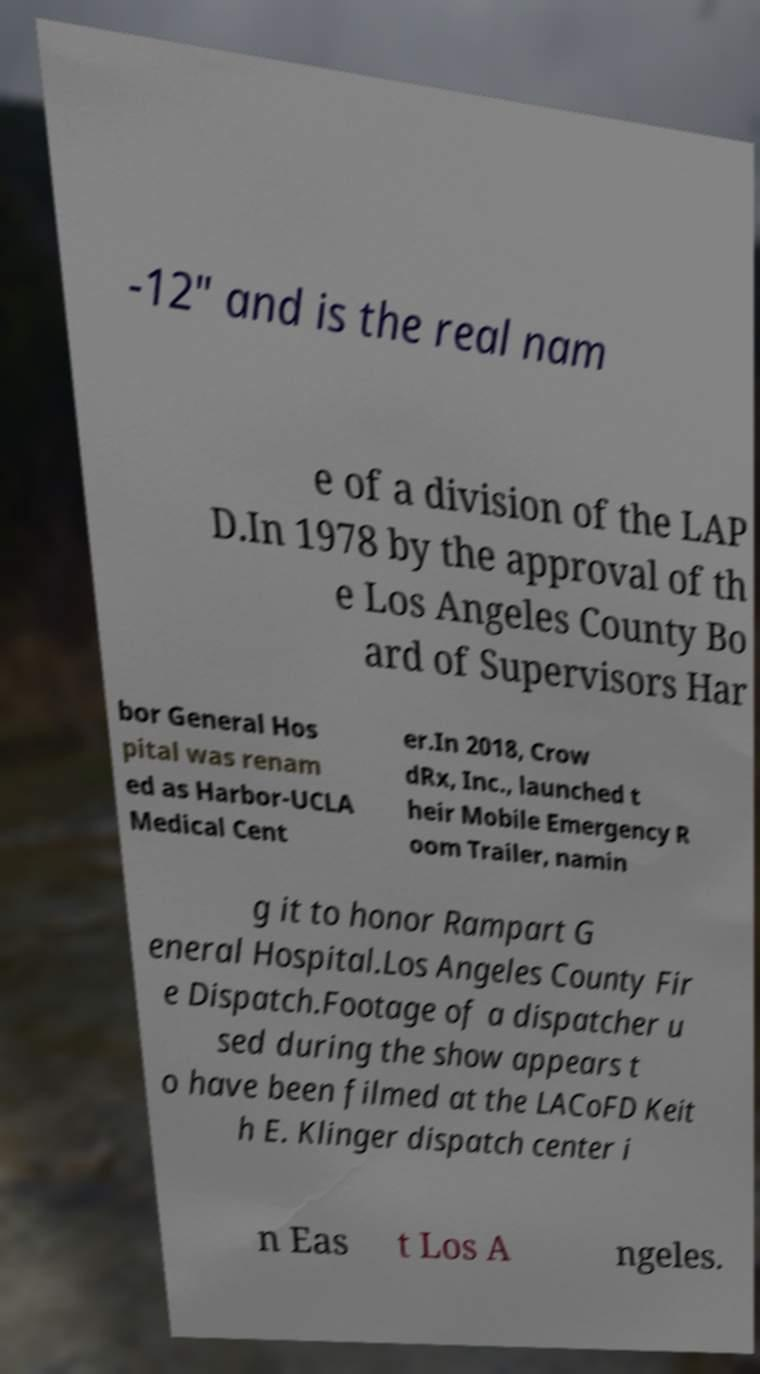Please read and relay the text visible in this image. What does it say? -12" and is the real nam e of a division of the LAP D.In 1978 by the approval of th e Los Angeles County Bo ard of Supervisors Har bor General Hos pital was renam ed as Harbor-UCLA Medical Cent er.In 2018, Crow dRx, Inc., launched t heir Mobile Emergency R oom Trailer, namin g it to honor Rampart G eneral Hospital.Los Angeles County Fir e Dispatch.Footage of a dispatcher u sed during the show appears t o have been filmed at the LACoFD Keit h E. Klinger dispatch center i n Eas t Los A ngeles. 